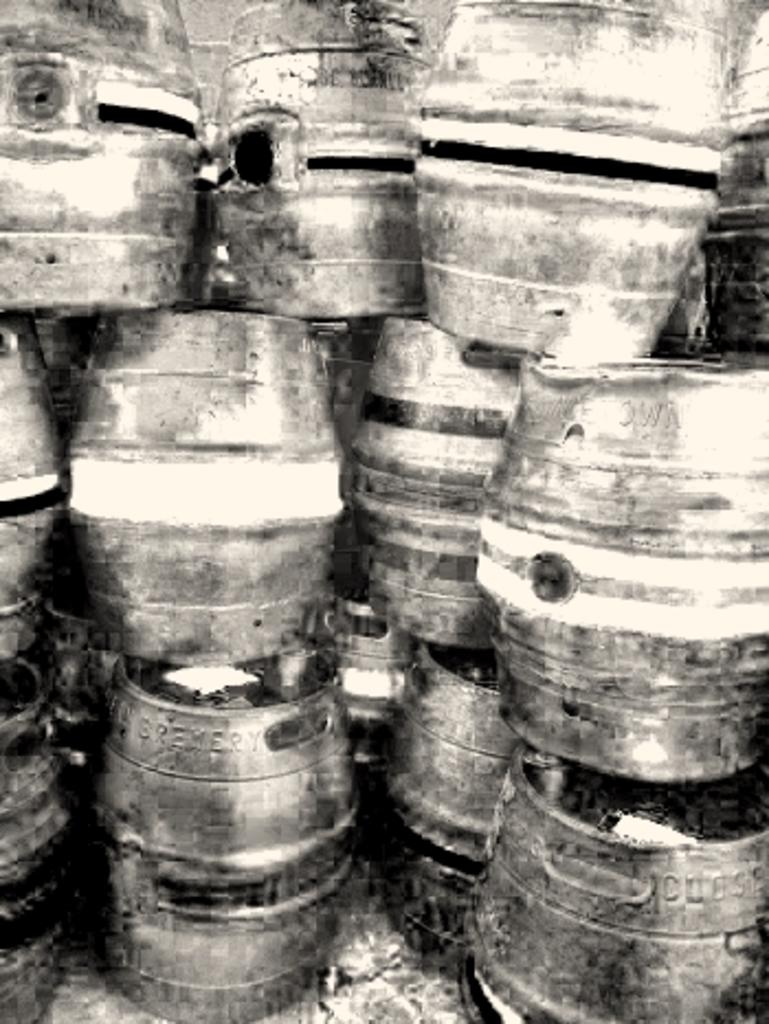What objects are present in the image? There are barrels in the image. Where are the barrels located? The barrels are placed on the land. What is the color scheme of the image? The image is black and white. What type of power source can be seen connected to the barrels in the image? There is no power source or cable visible in the image; it only shows barrels placed on the land. How much sugar is contained in the barrels in the image? There is no information about the contents of the barrels, so it cannot be determined if they contain sugar or any other substance. 